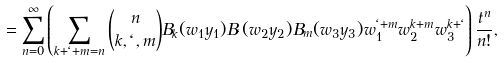<formula> <loc_0><loc_0><loc_500><loc_500>= \sum _ { n = 0 } ^ { \infty } \left ( \sum _ { k + \ell + m = n } \binom { n } { k , \ell , m } B _ { k } ( w _ { 1 } y _ { 1 } ) B _ { \ell } ( w _ { 2 } y _ { 2 } ) B _ { m } ( w _ { 3 } y _ { 3 } ) w _ { 1 } ^ { \ell + m } w _ { 2 } ^ { k + m } w _ { 3 } ^ { k + \ell } \right ) \frac { t ^ { n } } { n ! } ,</formula> 